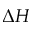<formula> <loc_0><loc_0><loc_500><loc_500>\Delta H</formula> 